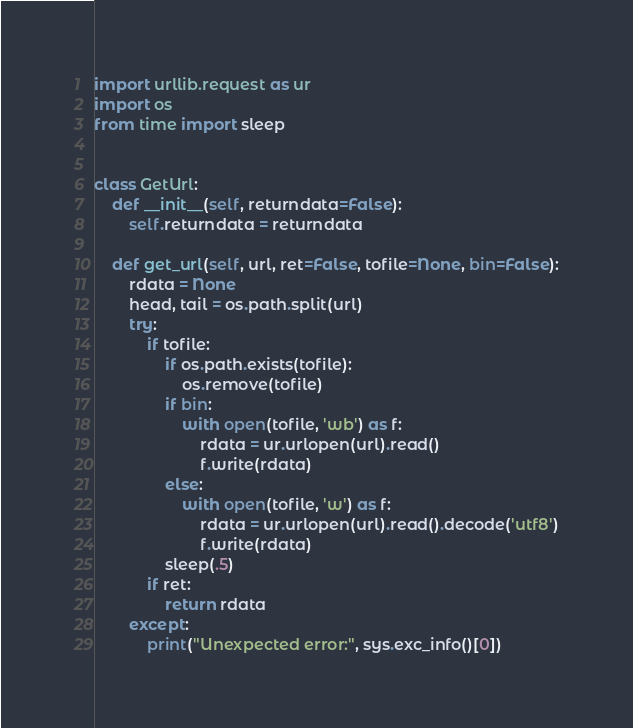<code> <loc_0><loc_0><loc_500><loc_500><_Python_>import urllib.request as ur
import os
from time import sleep


class GetUrl:
    def __init__(self, returndata=False):
        self.returndata = returndata

    def get_url(self, url, ret=False, tofile=None, bin=False):
        rdata = None
        head, tail = os.path.split(url)
        try:
            if tofile:
                if os.path.exists(tofile):
                    os.remove(tofile)
                if bin:
                    with open(tofile, 'wb') as f:
                        rdata = ur.urlopen(url).read()
                        f.write(rdata)
                else:
                    with open(tofile, 'w') as f:
                        rdata = ur.urlopen(url).read().decode('utf8')
                        f.write(rdata)
                sleep(.5)
            if ret:
                return rdata
        except:
            print("Unexpected error:", sys.exc_info()[0])
</code> 